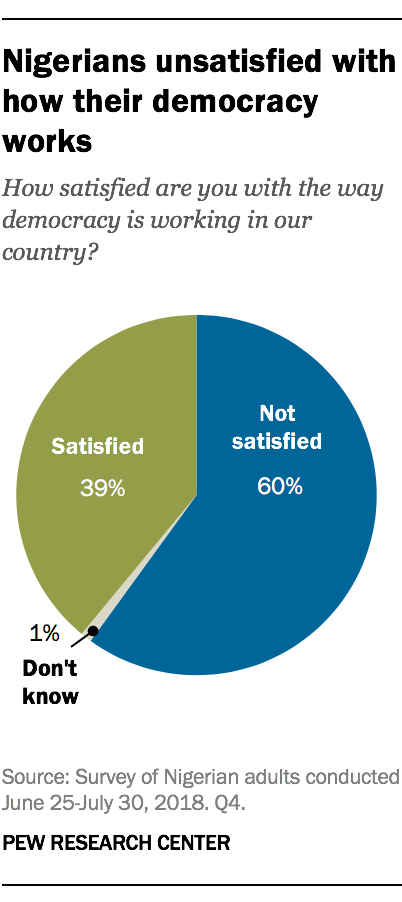Mention a couple of crucial points in this snapshot. The value of the blue section of the chart is 59 and the value of the grey section is the same. The biggest section of the chart is predominantly blue in color. 